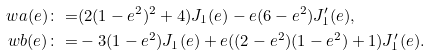Convert formula to latex. <formula><loc_0><loc_0><loc_500><loc_500>\ w a ( e ) \colon = & ( 2 ( 1 - e ^ { 2 } ) ^ { 2 } + 4 ) J _ { 1 } ( e ) - e ( 6 - e ^ { 2 } ) J _ { 1 } ^ { \prime } ( e ) , \\ \ w b ( e ) \colon = & - 3 ( 1 - e ^ { 2 } ) J _ { 1 } ( e ) + e ( ( 2 - e ^ { 2 } ) ( 1 - e ^ { 2 } ) + 1 ) J _ { 1 } ^ { \prime } ( e ) .</formula> 